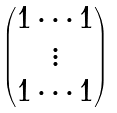Convert formula to latex. <formula><loc_0><loc_0><loc_500><loc_500>\begin{pmatrix} 1 \cdots 1 \\ \vdots \\ 1 \cdots 1 \end{pmatrix}</formula> 